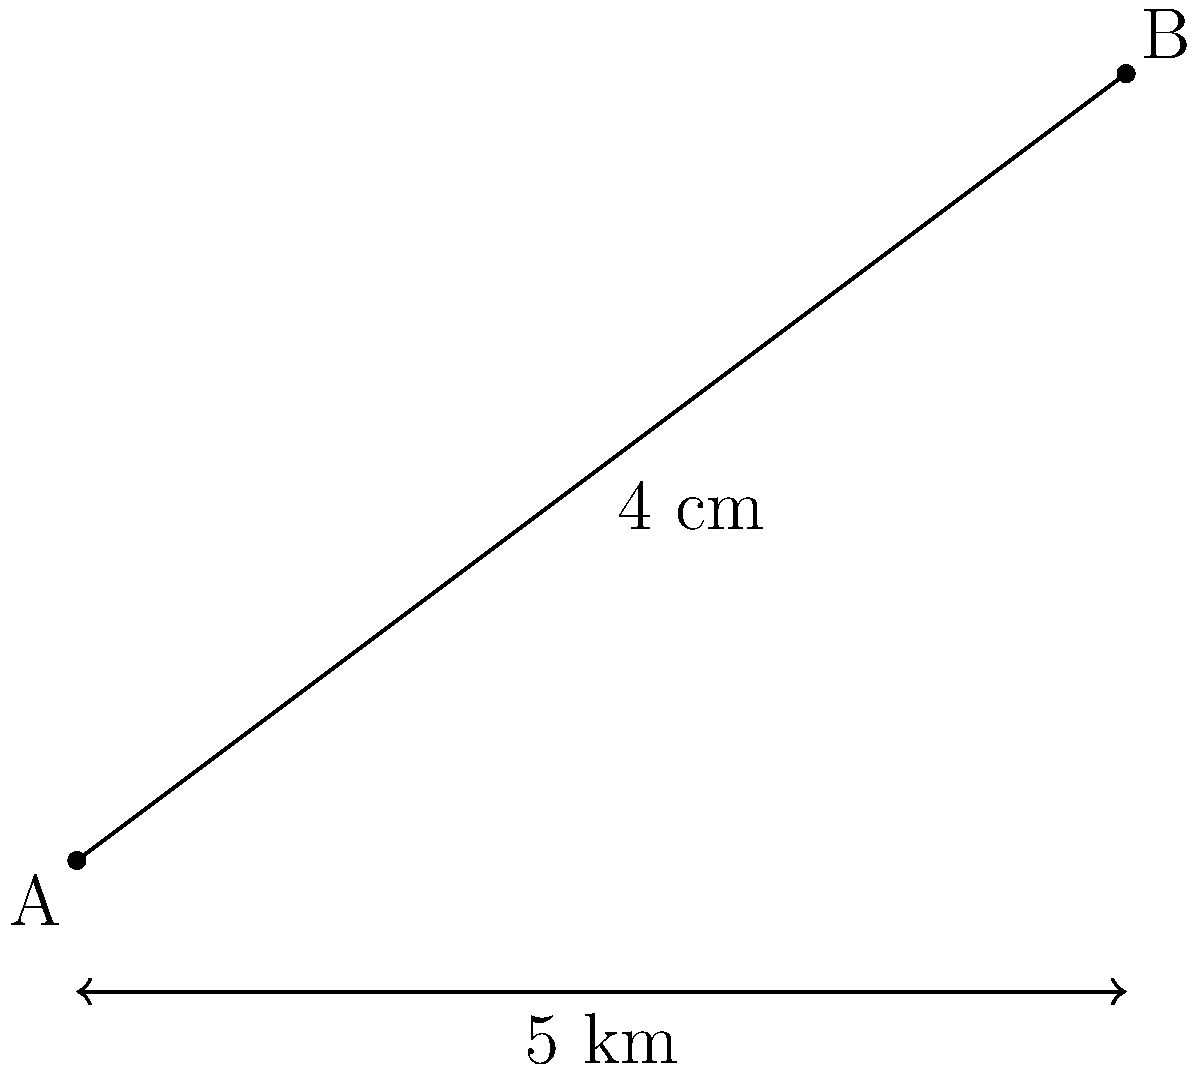On a scaled map of a disputed land parcel, two points A and B are 4 cm apart. If the map scale indicates that 1 cm represents 1.25 km on the actual land, what is the real distance between points A and B in kilometers? To solve this problem, we need to follow these steps:

1. Identify the scale of the map:
   1 cm on the map = 1.25 km in reality

2. Determine the distance between points A and B on the map:
   Distance on map = 4 cm

3. Set up a proportion to find the real distance:
   $\frac{1 \text{ cm}}{1.25 \text{ km}} = \frac{4 \text{ cm}}{x \text{ km}}$

4. Cross multiply:
   $1 \cdot x = 1.25 \cdot 4$

5. Solve for x:
   $x = 1.25 \cdot 4 = 5$

Therefore, the real distance between points A and B is 5 km.
Answer: 5 km 